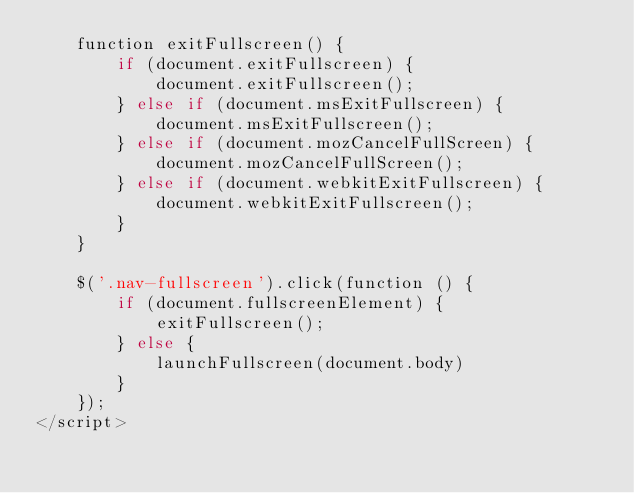<code> <loc_0><loc_0><loc_500><loc_500><_PHP_>    function exitFullscreen() {
        if (document.exitFullscreen) {
            document.exitFullscreen();
        } else if (document.msExitFullscreen) {
            document.msExitFullscreen();
        } else if (document.mozCancelFullScreen) {
            document.mozCancelFullScreen();
        } else if (document.webkitExitFullscreen) {
            document.webkitExitFullscreen();
        }
    }

    $('.nav-fullscreen').click(function () {
        if (document.fullscreenElement) {
            exitFullscreen();
        } else {
            launchFullscreen(document.body)
        }
    });
</script>
</code> 